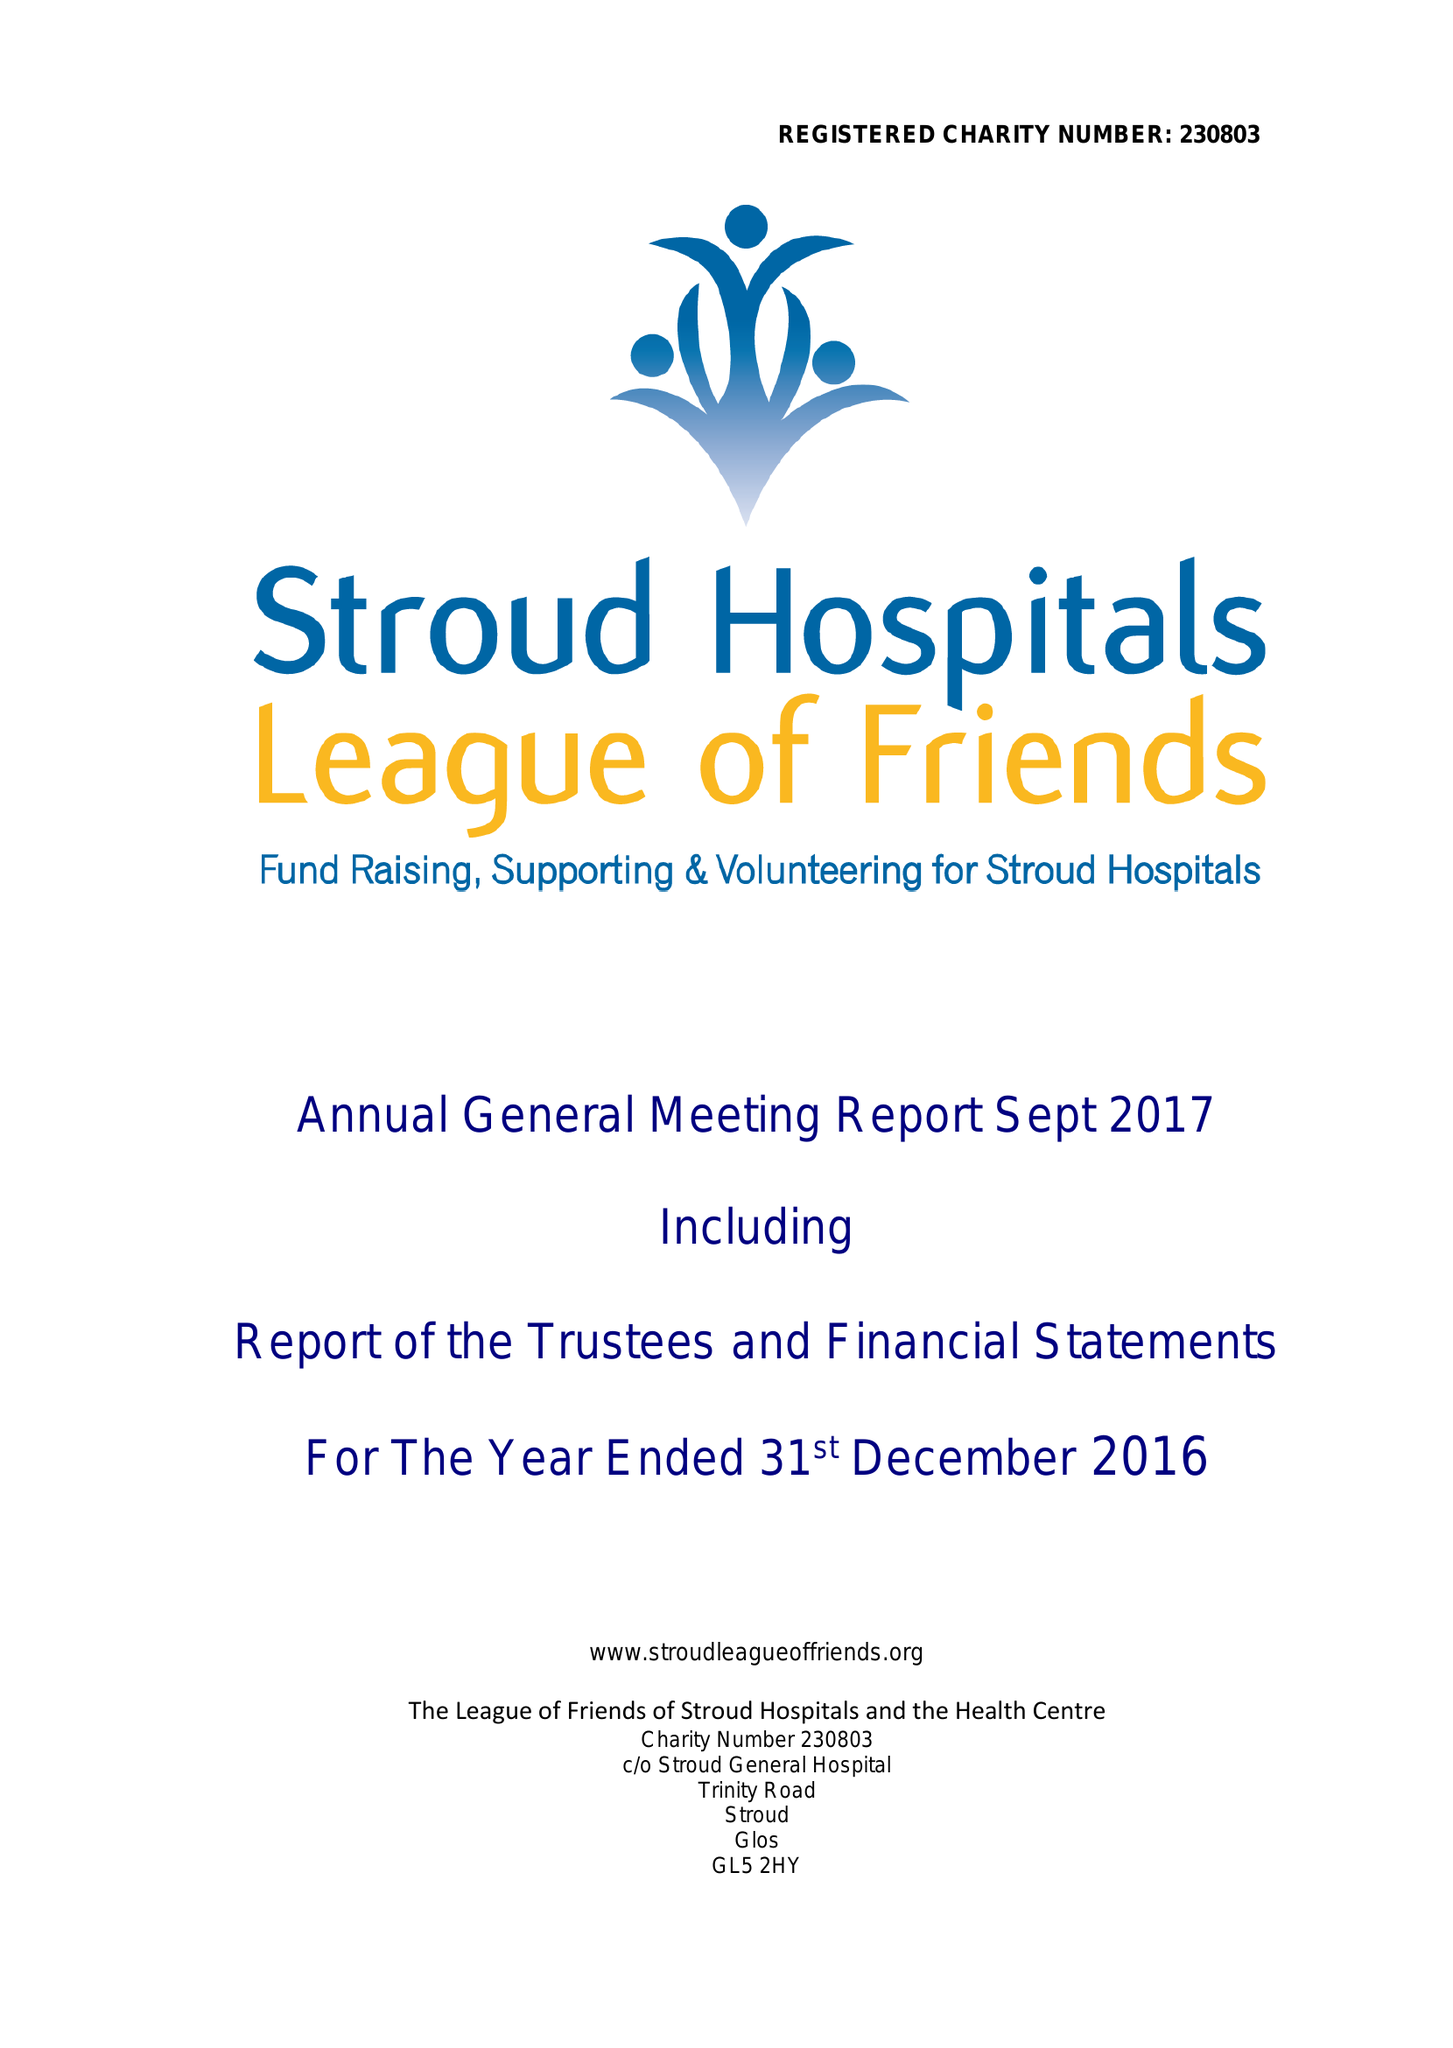What is the value for the charity_number?
Answer the question using a single word or phrase. 230803 